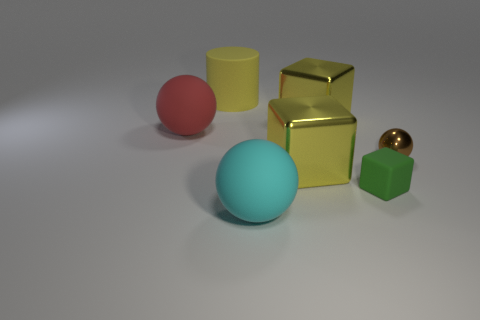Add 1 large yellow spheres. How many objects exist? 8 Subtract all cyan balls. How many balls are left? 2 Subtract all large metal cubes. How many cubes are left? 1 Subtract 0 red cylinders. How many objects are left? 7 Subtract all blocks. How many objects are left? 4 Subtract 1 cylinders. How many cylinders are left? 0 Subtract all cyan balls. Subtract all green cylinders. How many balls are left? 2 Subtract all green cylinders. How many cyan balls are left? 1 Subtract all large yellow metallic objects. Subtract all small matte objects. How many objects are left? 4 Add 2 large yellow matte objects. How many large yellow matte objects are left? 3 